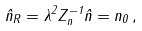<formula> <loc_0><loc_0><loc_500><loc_500>\hat { n } _ { R } = \lambda ^ { 2 } Z ^ { - 1 } _ { n } \hat { n } = n _ { 0 } \, ,</formula> 